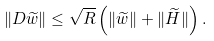<formula> <loc_0><loc_0><loc_500><loc_500>\| D \widetilde { w } \| \leq \sqrt { R } \left ( \| \widetilde { w } \| + \| \widetilde { H } \| \right ) .</formula> 